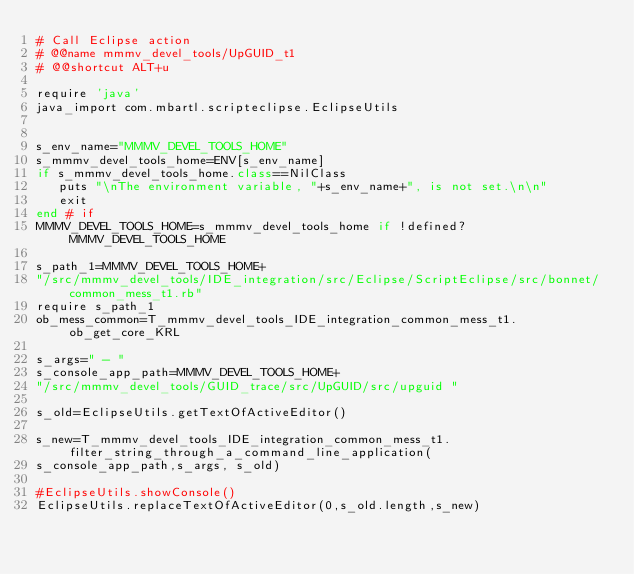Convert code to text. <code><loc_0><loc_0><loc_500><loc_500><_Ruby_># Call Eclipse action
# @@name mmmv_devel_tools/UpGUID_t1
# @@shortcut ALT+u

require 'java'
java_import com.mbartl.scripteclipse.EclipseUtils


s_env_name="MMMV_DEVEL_TOOLS_HOME"
s_mmmv_devel_tools_home=ENV[s_env_name]
if s_mmmv_devel_tools_home.class==NilClass
   puts "\nThe environment variable, "+s_env_name+", is not set.\n\n"
   exit
end # if
MMMV_DEVEL_TOOLS_HOME=s_mmmv_devel_tools_home if !defined? MMMV_DEVEL_TOOLS_HOME

s_path_1=MMMV_DEVEL_TOOLS_HOME+
"/src/mmmv_devel_tools/IDE_integration/src/Eclipse/ScriptEclipse/src/bonnet/common_mess_t1.rb"
require s_path_1
ob_mess_common=T_mmmv_devel_tools_IDE_integration_common_mess_t1.ob_get_core_KRL

s_args=" - "
s_console_app_path=MMMV_DEVEL_TOOLS_HOME+
"/src/mmmv_devel_tools/GUID_trace/src/UpGUID/src/upguid "

s_old=EclipseUtils.getTextOfActiveEditor()

s_new=T_mmmv_devel_tools_IDE_integration_common_mess_t1.filter_string_through_a_command_line_application(
s_console_app_path,s_args, s_old)

#EclipseUtils.showConsole()
EclipseUtils.replaceTextOfActiveEditor(0,s_old.length,s_new)



</code> 